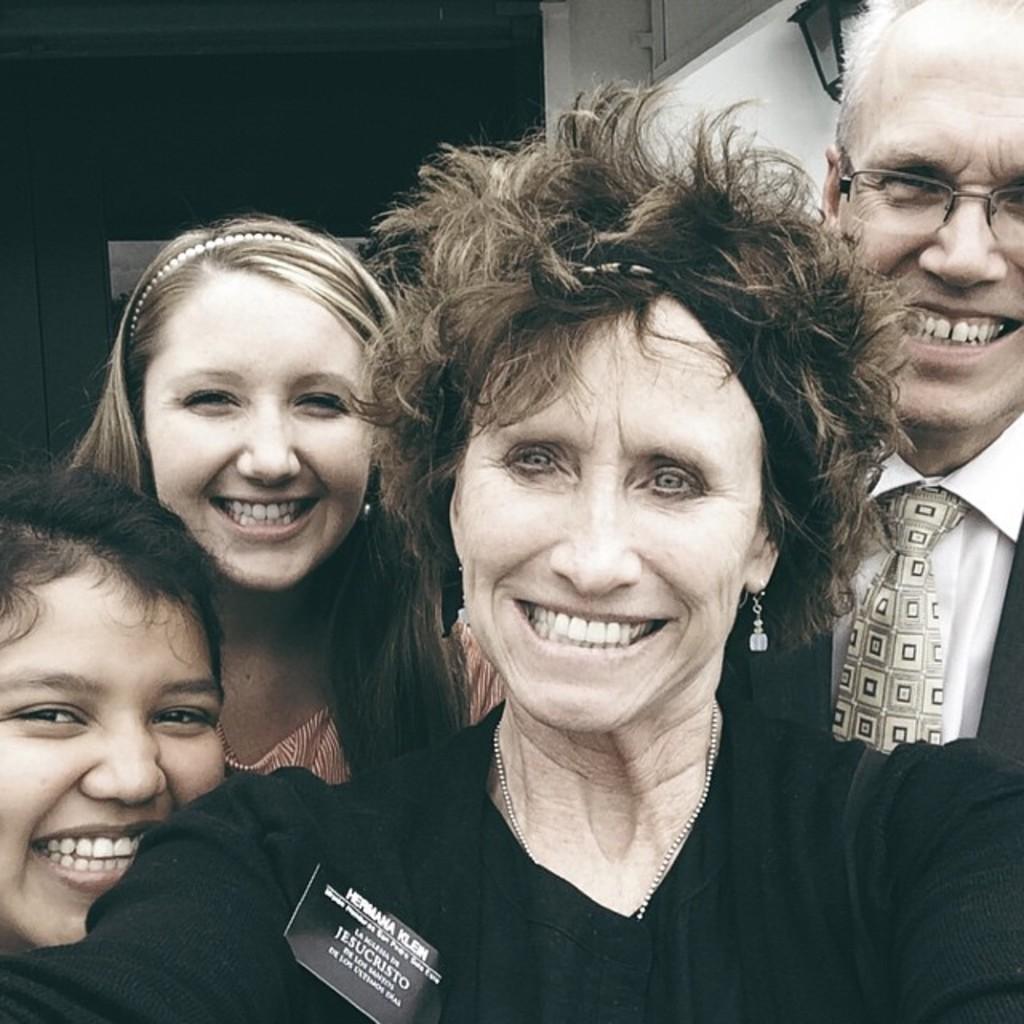Please provide a concise description of this image. This picture we can see group of people, they are all smiling, on the right side of the image we can see a man, he wore spectacles, in the background we can see a light. 